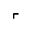Convert formula to latex. <formula><loc_0><loc_0><loc_500><loc_500>\ulcorner</formula> 